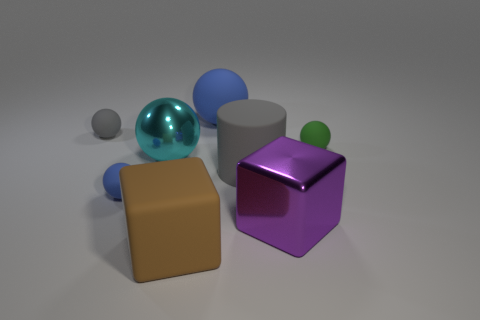There is a metallic object in front of the big sphere in front of the gray sphere; what color is it?
Provide a succinct answer. Purple. What color is the matte cube?
Provide a succinct answer. Brown. Is there a object of the same color as the big cylinder?
Your answer should be compact. Yes. Do the tiny ball in front of the gray cylinder and the big rubber ball have the same color?
Give a very brief answer. Yes. How many objects are either blue matte balls in front of the small gray object or spheres?
Provide a short and direct response. 5. There is a gray matte cylinder; are there any big gray matte cylinders in front of it?
Keep it short and to the point. No. What material is the tiny ball that is the same color as the big cylinder?
Offer a terse response. Rubber. Does the tiny ball in front of the cylinder have the same material as the big cylinder?
Your answer should be compact. Yes. Are there any big blue balls that are behind the blue object that is behind the sphere that is right of the big gray thing?
Make the answer very short. No. What number of balls are either big objects or blue objects?
Offer a very short reply. 3. 